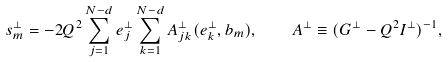<formula> <loc_0><loc_0><loc_500><loc_500>s _ { m } ^ { \bot } = - 2 Q ^ { 2 } \sum _ { j = 1 } ^ { N - d } e _ { j } ^ { \bot } \sum _ { k = 1 } ^ { N - d } A _ { j k } ^ { \bot } ( e _ { k } ^ { \bot } , b _ { m } ) , \quad A ^ { \bot } \equiv ( G ^ { \bot } - Q ^ { 2 } I ^ { \bot } ) ^ { - 1 } ,</formula> 